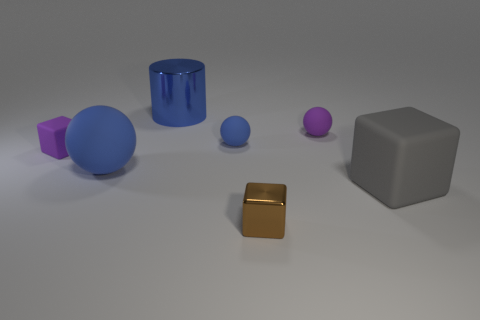Add 1 small purple objects. How many objects exist? 8 Subtract all balls. How many objects are left? 4 Subtract 0 brown balls. How many objects are left? 7 Subtract all big metal cylinders. Subtract all tiny red metallic balls. How many objects are left? 6 Add 4 gray objects. How many gray objects are left? 5 Add 6 blue cylinders. How many blue cylinders exist? 7 